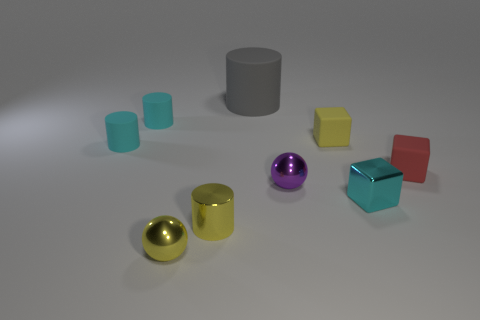Subtract all blue cylinders. Subtract all gray balls. How many cylinders are left? 4 Add 1 cyan matte spheres. How many objects exist? 10 Subtract all balls. How many objects are left? 7 Add 8 tiny yellow rubber cubes. How many tiny yellow rubber cubes are left? 9 Add 3 yellow metal blocks. How many yellow metal blocks exist? 3 Subtract 0 green cubes. How many objects are left? 9 Subtract all small gray shiny cylinders. Subtract all cylinders. How many objects are left? 5 